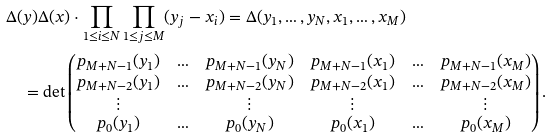<formula> <loc_0><loc_0><loc_500><loc_500>& \Delta ( y ) \Delta ( x ) \cdot \prod _ { 1 \leq i \leq N } \prod _ { 1 \leq j \leq M } ( y _ { j } - x _ { i } ) = \Delta ( y _ { 1 } , \dots , y _ { N } , x _ { 1 } , \dots , x _ { M } ) \\ & \quad = \det \begin{pmatrix} p _ { M + N - 1 } ( y _ { 1 } ) & \hdots & p _ { M + N - 1 } ( y _ { N } ) & p _ { M + N - 1 } ( x _ { 1 } ) & \hdots & p _ { M + N - 1 } ( x _ { M } ) \\ p _ { M + N - 2 } ( y _ { 1 } ) & \hdots & p _ { M + N - 2 } ( y _ { N } ) & p _ { M + N - 2 } ( x _ { 1 } ) & \hdots & p _ { M + N - 2 } ( x _ { M } ) \\ \vdots & & \vdots & \vdots & & \vdots \\ p _ { 0 } ( y _ { 1 } ) & \hdots & p _ { 0 } ( y _ { N } ) & p _ { 0 } ( x _ { 1 } ) & \hdots & p _ { 0 } ( x _ { M } ) \end{pmatrix} .</formula> 